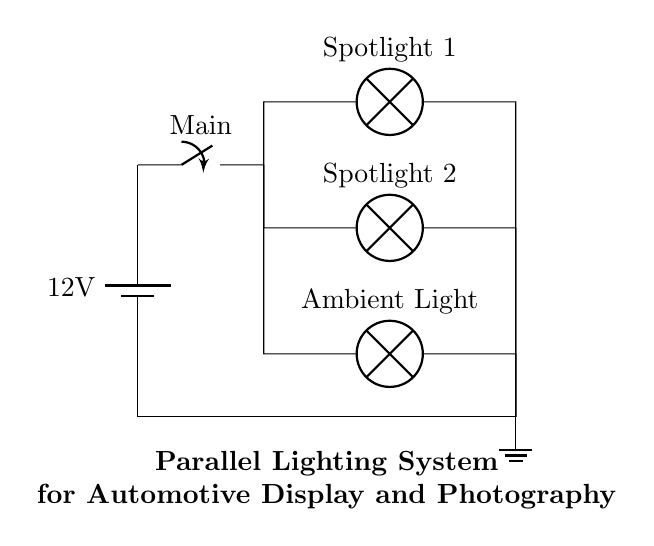What is the power source voltage? The circuit shows a battery labeled with a voltage of 12 volts connected as the power source.
Answer: 12 volts How many spotlights are in this circuit? There are two lamps labeled as "Spotlight 1" and "Spotlight 2", each representing a distinct spotlight in the parallel branches of the circuit.
Answer: Two What type of lighting is included besides spotlights? The circuit has an additional lamp labeled "Ambient Light", indicating it provides a different type of lighting alongside the two spotlights.
Answer: Ambient Light What is the role of the main switch? The main switch connects the battery to the parallel branches of the lights, allowing control over whether the entire lighting system is powered on or off.
Answer: Control What is the circuit configuration used? The lighting system is arranged in parallel, as indicated by the branches leading from the main switch to each lamp, allowing each light to operate independently.
Answer: Parallel Which connection point serves as the ground? The circuit includes a connection that leads to a ground symbol, indicating that it serves as the reference point for the electrical circuit.
Answer: Ground 